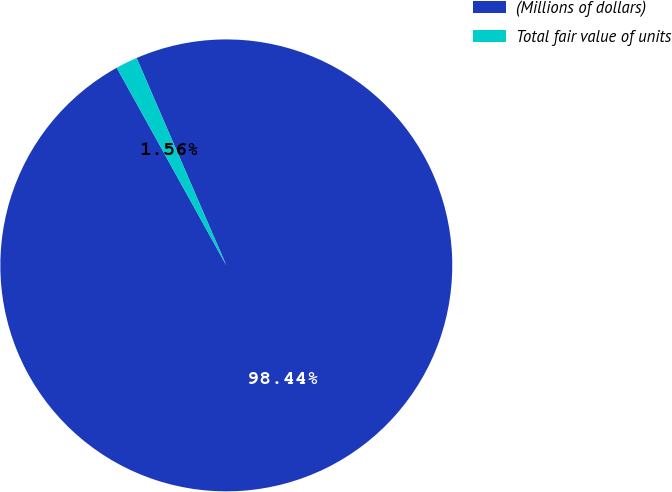Convert chart. <chart><loc_0><loc_0><loc_500><loc_500><pie_chart><fcel>(Millions of dollars)<fcel>Total fair value of units<nl><fcel>98.44%<fcel>1.56%<nl></chart> 